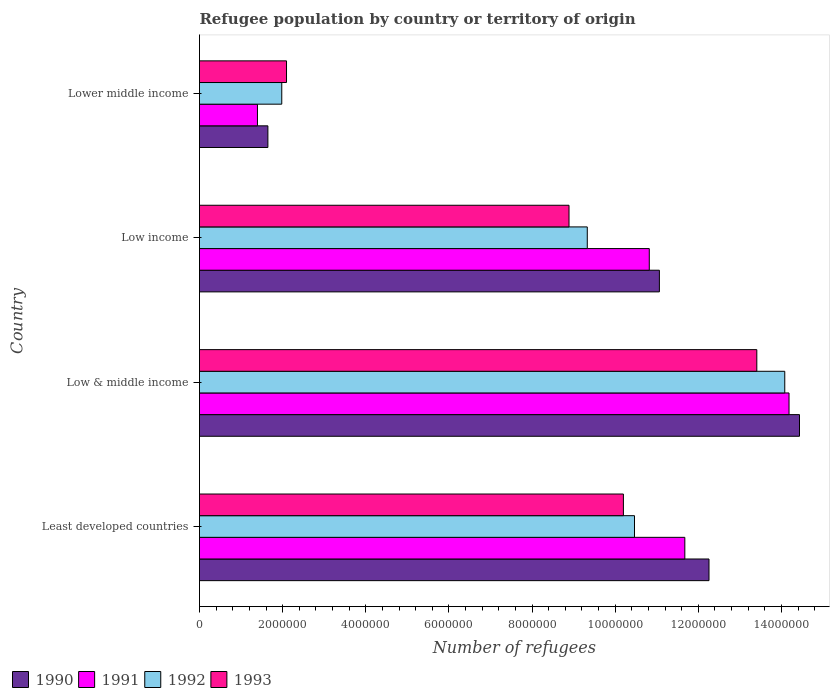How many different coloured bars are there?
Your answer should be very brief. 4. How many groups of bars are there?
Ensure brevity in your answer.  4. Are the number of bars on each tick of the Y-axis equal?
Your answer should be compact. Yes. How many bars are there on the 1st tick from the bottom?
Offer a very short reply. 4. What is the label of the 3rd group of bars from the top?
Provide a succinct answer. Low & middle income. What is the number of refugees in 1990 in Low & middle income?
Keep it short and to the point. 1.44e+07. Across all countries, what is the maximum number of refugees in 1993?
Make the answer very short. 1.34e+07. Across all countries, what is the minimum number of refugees in 1993?
Provide a short and direct response. 2.09e+06. In which country was the number of refugees in 1992 minimum?
Provide a succinct answer. Lower middle income. What is the total number of refugees in 1990 in the graph?
Make the answer very short. 3.94e+07. What is the difference between the number of refugees in 1993 in Low & middle income and that in Low income?
Give a very brief answer. 4.52e+06. What is the difference between the number of refugees in 1990 in Lower middle income and the number of refugees in 1993 in Low & middle income?
Give a very brief answer. -1.18e+07. What is the average number of refugees in 1990 per country?
Provide a short and direct response. 9.85e+06. What is the difference between the number of refugees in 1991 and number of refugees in 1992 in Low income?
Offer a terse response. 1.49e+06. In how many countries, is the number of refugees in 1991 greater than 10000000 ?
Your response must be concise. 3. What is the ratio of the number of refugees in 1992 in Least developed countries to that in Low income?
Make the answer very short. 1.12. What is the difference between the highest and the second highest number of refugees in 1993?
Make the answer very short. 3.21e+06. What is the difference between the highest and the lowest number of refugees in 1990?
Keep it short and to the point. 1.28e+07. In how many countries, is the number of refugees in 1991 greater than the average number of refugees in 1991 taken over all countries?
Keep it short and to the point. 3. Is the sum of the number of refugees in 1992 in Least developed countries and Lower middle income greater than the maximum number of refugees in 1990 across all countries?
Your response must be concise. No. How many bars are there?
Keep it short and to the point. 16. How many countries are there in the graph?
Ensure brevity in your answer.  4. What is the difference between two consecutive major ticks on the X-axis?
Offer a very short reply. 2.00e+06. Where does the legend appear in the graph?
Your answer should be compact. Bottom left. How are the legend labels stacked?
Provide a succinct answer. Horizontal. What is the title of the graph?
Offer a very short reply. Refugee population by country or territory of origin. What is the label or title of the X-axis?
Give a very brief answer. Number of refugees. What is the label or title of the Y-axis?
Offer a terse response. Country. What is the Number of refugees of 1990 in Least developed countries?
Make the answer very short. 1.23e+07. What is the Number of refugees in 1991 in Least developed countries?
Keep it short and to the point. 1.17e+07. What is the Number of refugees of 1992 in Least developed countries?
Make the answer very short. 1.05e+07. What is the Number of refugees in 1993 in Least developed countries?
Keep it short and to the point. 1.02e+07. What is the Number of refugees in 1990 in Low & middle income?
Your response must be concise. 1.44e+07. What is the Number of refugees in 1991 in Low & middle income?
Your answer should be very brief. 1.42e+07. What is the Number of refugees in 1992 in Low & middle income?
Provide a short and direct response. 1.41e+07. What is the Number of refugees of 1993 in Low & middle income?
Offer a very short reply. 1.34e+07. What is the Number of refugees in 1990 in Low income?
Your answer should be very brief. 1.11e+07. What is the Number of refugees of 1991 in Low income?
Provide a short and direct response. 1.08e+07. What is the Number of refugees in 1992 in Low income?
Offer a very short reply. 9.33e+06. What is the Number of refugees in 1993 in Low income?
Make the answer very short. 8.89e+06. What is the Number of refugees of 1990 in Lower middle income?
Offer a terse response. 1.65e+06. What is the Number of refugees in 1991 in Lower middle income?
Give a very brief answer. 1.39e+06. What is the Number of refugees of 1992 in Lower middle income?
Offer a very short reply. 1.98e+06. What is the Number of refugees in 1993 in Lower middle income?
Give a very brief answer. 2.09e+06. Across all countries, what is the maximum Number of refugees of 1990?
Keep it short and to the point. 1.44e+07. Across all countries, what is the maximum Number of refugees of 1991?
Offer a very short reply. 1.42e+07. Across all countries, what is the maximum Number of refugees of 1992?
Your answer should be compact. 1.41e+07. Across all countries, what is the maximum Number of refugees in 1993?
Keep it short and to the point. 1.34e+07. Across all countries, what is the minimum Number of refugees of 1990?
Ensure brevity in your answer.  1.65e+06. Across all countries, what is the minimum Number of refugees in 1991?
Provide a short and direct response. 1.39e+06. Across all countries, what is the minimum Number of refugees in 1992?
Ensure brevity in your answer.  1.98e+06. Across all countries, what is the minimum Number of refugees of 1993?
Your response must be concise. 2.09e+06. What is the total Number of refugees in 1990 in the graph?
Offer a terse response. 3.94e+07. What is the total Number of refugees in 1991 in the graph?
Your response must be concise. 3.81e+07. What is the total Number of refugees of 1992 in the graph?
Your answer should be very brief. 3.59e+07. What is the total Number of refugees of 1993 in the graph?
Offer a terse response. 3.46e+07. What is the difference between the Number of refugees in 1990 in Least developed countries and that in Low & middle income?
Ensure brevity in your answer.  -2.18e+06. What is the difference between the Number of refugees in 1991 in Least developed countries and that in Low & middle income?
Provide a succinct answer. -2.51e+06. What is the difference between the Number of refugees of 1992 in Least developed countries and that in Low & middle income?
Your answer should be compact. -3.62e+06. What is the difference between the Number of refugees in 1993 in Least developed countries and that in Low & middle income?
Give a very brief answer. -3.21e+06. What is the difference between the Number of refugees in 1990 in Least developed countries and that in Low income?
Provide a succinct answer. 1.19e+06. What is the difference between the Number of refugees of 1991 in Least developed countries and that in Low income?
Offer a terse response. 8.55e+05. What is the difference between the Number of refugees of 1992 in Least developed countries and that in Low income?
Offer a terse response. 1.14e+06. What is the difference between the Number of refugees in 1993 in Least developed countries and that in Low income?
Provide a short and direct response. 1.31e+06. What is the difference between the Number of refugees of 1990 in Least developed countries and that in Lower middle income?
Your answer should be very brief. 1.06e+07. What is the difference between the Number of refugees of 1991 in Least developed countries and that in Lower middle income?
Your response must be concise. 1.03e+07. What is the difference between the Number of refugees in 1992 in Least developed countries and that in Lower middle income?
Ensure brevity in your answer.  8.49e+06. What is the difference between the Number of refugees in 1993 in Least developed countries and that in Lower middle income?
Offer a very short reply. 8.11e+06. What is the difference between the Number of refugees of 1990 in Low & middle income and that in Low income?
Your answer should be compact. 3.37e+06. What is the difference between the Number of refugees of 1991 in Low & middle income and that in Low income?
Your answer should be very brief. 3.36e+06. What is the difference between the Number of refugees of 1992 in Low & middle income and that in Low income?
Your response must be concise. 4.75e+06. What is the difference between the Number of refugees in 1993 in Low & middle income and that in Low income?
Offer a terse response. 4.52e+06. What is the difference between the Number of refugees of 1990 in Low & middle income and that in Lower middle income?
Your response must be concise. 1.28e+07. What is the difference between the Number of refugees in 1991 in Low & middle income and that in Lower middle income?
Give a very brief answer. 1.28e+07. What is the difference between the Number of refugees in 1992 in Low & middle income and that in Lower middle income?
Keep it short and to the point. 1.21e+07. What is the difference between the Number of refugees of 1993 in Low & middle income and that in Lower middle income?
Offer a very short reply. 1.13e+07. What is the difference between the Number of refugees of 1990 in Low income and that in Lower middle income?
Keep it short and to the point. 9.42e+06. What is the difference between the Number of refugees in 1991 in Low income and that in Lower middle income?
Your answer should be very brief. 9.43e+06. What is the difference between the Number of refugees of 1992 in Low income and that in Lower middle income?
Offer a terse response. 7.35e+06. What is the difference between the Number of refugees in 1993 in Low income and that in Lower middle income?
Provide a short and direct response. 6.80e+06. What is the difference between the Number of refugees in 1990 in Least developed countries and the Number of refugees in 1991 in Low & middle income?
Provide a short and direct response. -1.93e+06. What is the difference between the Number of refugees of 1990 in Least developed countries and the Number of refugees of 1992 in Low & middle income?
Give a very brief answer. -1.82e+06. What is the difference between the Number of refugees of 1990 in Least developed countries and the Number of refugees of 1993 in Low & middle income?
Provide a succinct answer. -1.15e+06. What is the difference between the Number of refugees in 1991 in Least developed countries and the Number of refugees in 1992 in Low & middle income?
Provide a succinct answer. -2.40e+06. What is the difference between the Number of refugees in 1991 in Least developed countries and the Number of refugees in 1993 in Low & middle income?
Offer a terse response. -1.73e+06. What is the difference between the Number of refugees in 1992 in Least developed countries and the Number of refugees in 1993 in Low & middle income?
Offer a very short reply. -2.94e+06. What is the difference between the Number of refugees of 1990 in Least developed countries and the Number of refugees of 1991 in Low income?
Provide a short and direct response. 1.44e+06. What is the difference between the Number of refugees in 1990 in Least developed countries and the Number of refugees in 1992 in Low income?
Provide a succinct answer. 2.93e+06. What is the difference between the Number of refugees of 1990 in Least developed countries and the Number of refugees of 1993 in Low income?
Your answer should be very brief. 3.37e+06. What is the difference between the Number of refugees of 1991 in Least developed countries and the Number of refugees of 1992 in Low income?
Offer a terse response. 2.35e+06. What is the difference between the Number of refugees in 1991 in Least developed countries and the Number of refugees in 1993 in Low income?
Make the answer very short. 2.79e+06. What is the difference between the Number of refugees in 1992 in Least developed countries and the Number of refugees in 1993 in Low income?
Offer a very short reply. 1.58e+06. What is the difference between the Number of refugees in 1990 in Least developed countries and the Number of refugees in 1991 in Lower middle income?
Provide a short and direct response. 1.09e+07. What is the difference between the Number of refugees in 1990 in Least developed countries and the Number of refugees in 1992 in Lower middle income?
Offer a very short reply. 1.03e+07. What is the difference between the Number of refugees in 1990 in Least developed countries and the Number of refugees in 1993 in Lower middle income?
Make the answer very short. 1.02e+07. What is the difference between the Number of refugees in 1991 in Least developed countries and the Number of refugees in 1992 in Lower middle income?
Provide a succinct answer. 9.70e+06. What is the difference between the Number of refugees in 1991 in Least developed countries and the Number of refugees in 1993 in Lower middle income?
Your response must be concise. 9.58e+06. What is the difference between the Number of refugees of 1992 in Least developed countries and the Number of refugees of 1993 in Lower middle income?
Make the answer very short. 8.37e+06. What is the difference between the Number of refugees of 1990 in Low & middle income and the Number of refugees of 1991 in Low income?
Your response must be concise. 3.61e+06. What is the difference between the Number of refugees of 1990 in Low & middle income and the Number of refugees of 1992 in Low income?
Provide a succinct answer. 5.11e+06. What is the difference between the Number of refugees of 1990 in Low & middle income and the Number of refugees of 1993 in Low income?
Offer a terse response. 5.55e+06. What is the difference between the Number of refugees in 1991 in Low & middle income and the Number of refugees in 1992 in Low income?
Keep it short and to the point. 4.85e+06. What is the difference between the Number of refugees in 1991 in Low & middle income and the Number of refugees in 1993 in Low income?
Offer a very short reply. 5.29e+06. What is the difference between the Number of refugees in 1992 in Low & middle income and the Number of refugees in 1993 in Low income?
Keep it short and to the point. 5.19e+06. What is the difference between the Number of refugees of 1990 in Low & middle income and the Number of refugees of 1991 in Lower middle income?
Keep it short and to the point. 1.30e+07. What is the difference between the Number of refugees in 1990 in Low & middle income and the Number of refugees in 1992 in Lower middle income?
Your answer should be very brief. 1.25e+07. What is the difference between the Number of refugees of 1990 in Low & middle income and the Number of refugees of 1993 in Lower middle income?
Make the answer very short. 1.23e+07. What is the difference between the Number of refugees in 1991 in Low & middle income and the Number of refugees in 1992 in Lower middle income?
Keep it short and to the point. 1.22e+07. What is the difference between the Number of refugees in 1991 in Low & middle income and the Number of refugees in 1993 in Lower middle income?
Make the answer very short. 1.21e+07. What is the difference between the Number of refugees of 1992 in Low & middle income and the Number of refugees of 1993 in Lower middle income?
Offer a terse response. 1.20e+07. What is the difference between the Number of refugees of 1990 in Low income and the Number of refugees of 1991 in Lower middle income?
Give a very brief answer. 9.67e+06. What is the difference between the Number of refugees of 1990 in Low income and the Number of refugees of 1992 in Lower middle income?
Keep it short and to the point. 9.09e+06. What is the difference between the Number of refugees in 1990 in Low income and the Number of refugees in 1993 in Lower middle income?
Make the answer very short. 8.97e+06. What is the difference between the Number of refugees in 1991 in Low income and the Number of refugees in 1992 in Lower middle income?
Provide a short and direct response. 8.84e+06. What is the difference between the Number of refugees of 1991 in Low income and the Number of refugees of 1993 in Lower middle income?
Give a very brief answer. 8.73e+06. What is the difference between the Number of refugees of 1992 in Low income and the Number of refugees of 1993 in Lower middle income?
Your answer should be very brief. 7.24e+06. What is the average Number of refugees in 1990 per country?
Your answer should be very brief. 9.85e+06. What is the average Number of refugees of 1991 per country?
Your response must be concise. 9.52e+06. What is the average Number of refugees in 1992 per country?
Offer a very short reply. 8.96e+06. What is the average Number of refugees of 1993 per country?
Your response must be concise. 8.65e+06. What is the difference between the Number of refugees in 1990 and Number of refugees in 1991 in Least developed countries?
Give a very brief answer. 5.82e+05. What is the difference between the Number of refugees in 1990 and Number of refugees in 1992 in Least developed countries?
Give a very brief answer. 1.79e+06. What is the difference between the Number of refugees in 1990 and Number of refugees in 1993 in Least developed countries?
Offer a very short reply. 2.06e+06. What is the difference between the Number of refugees of 1991 and Number of refugees of 1992 in Least developed countries?
Give a very brief answer. 1.21e+06. What is the difference between the Number of refugees in 1991 and Number of refugees in 1993 in Least developed countries?
Your answer should be very brief. 1.48e+06. What is the difference between the Number of refugees of 1992 and Number of refugees of 1993 in Least developed countries?
Make the answer very short. 2.67e+05. What is the difference between the Number of refugees in 1990 and Number of refugees in 1991 in Low & middle income?
Your answer should be very brief. 2.52e+05. What is the difference between the Number of refugees of 1990 and Number of refugees of 1992 in Low & middle income?
Keep it short and to the point. 3.54e+05. What is the difference between the Number of refugees in 1990 and Number of refugees in 1993 in Low & middle income?
Offer a very short reply. 1.03e+06. What is the difference between the Number of refugees in 1991 and Number of refugees in 1992 in Low & middle income?
Your answer should be compact. 1.02e+05. What is the difference between the Number of refugees in 1991 and Number of refugees in 1993 in Low & middle income?
Offer a terse response. 7.75e+05. What is the difference between the Number of refugees of 1992 and Number of refugees of 1993 in Low & middle income?
Your response must be concise. 6.73e+05. What is the difference between the Number of refugees in 1990 and Number of refugees in 1991 in Low income?
Make the answer very short. 2.43e+05. What is the difference between the Number of refugees of 1990 and Number of refugees of 1992 in Low income?
Offer a terse response. 1.73e+06. What is the difference between the Number of refugees in 1990 and Number of refugees in 1993 in Low income?
Keep it short and to the point. 2.17e+06. What is the difference between the Number of refugees of 1991 and Number of refugees of 1992 in Low income?
Provide a succinct answer. 1.49e+06. What is the difference between the Number of refugees in 1991 and Number of refugees in 1993 in Low income?
Keep it short and to the point. 1.93e+06. What is the difference between the Number of refugees in 1992 and Number of refugees in 1993 in Low income?
Your answer should be very brief. 4.40e+05. What is the difference between the Number of refugees in 1990 and Number of refugees in 1991 in Lower middle income?
Give a very brief answer. 2.51e+05. What is the difference between the Number of refugees in 1990 and Number of refugees in 1992 in Lower middle income?
Give a very brief answer. -3.34e+05. What is the difference between the Number of refugees in 1990 and Number of refugees in 1993 in Lower middle income?
Provide a succinct answer. -4.48e+05. What is the difference between the Number of refugees in 1991 and Number of refugees in 1992 in Lower middle income?
Your answer should be very brief. -5.85e+05. What is the difference between the Number of refugees of 1991 and Number of refugees of 1993 in Lower middle income?
Give a very brief answer. -6.99e+05. What is the difference between the Number of refugees of 1992 and Number of refugees of 1993 in Lower middle income?
Keep it short and to the point. -1.15e+05. What is the ratio of the Number of refugees in 1990 in Least developed countries to that in Low & middle income?
Your response must be concise. 0.85. What is the ratio of the Number of refugees of 1991 in Least developed countries to that in Low & middle income?
Give a very brief answer. 0.82. What is the ratio of the Number of refugees of 1992 in Least developed countries to that in Low & middle income?
Give a very brief answer. 0.74. What is the ratio of the Number of refugees in 1993 in Least developed countries to that in Low & middle income?
Give a very brief answer. 0.76. What is the ratio of the Number of refugees in 1990 in Least developed countries to that in Low income?
Your answer should be compact. 1.11. What is the ratio of the Number of refugees of 1991 in Least developed countries to that in Low income?
Offer a very short reply. 1.08. What is the ratio of the Number of refugees of 1992 in Least developed countries to that in Low income?
Your answer should be compact. 1.12. What is the ratio of the Number of refugees in 1993 in Least developed countries to that in Low income?
Ensure brevity in your answer.  1.15. What is the ratio of the Number of refugees in 1990 in Least developed countries to that in Lower middle income?
Offer a terse response. 7.45. What is the ratio of the Number of refugees of 1991 in Least developed countries to that in Lower middle income?
Provide a short and direct response. 8.37. What is the ratio of the Number of refugees of 1992 in Least developed countries to that in Lower middle income?
Offer a very short reply. 5.29. What is the ratio of the Number of refugees of 1993 in Least developed countries to that in Lower middle income?
Keep it short and to the point. 4.87. What is the ratio of the Number of refugees of 1990 in Low & middle income to that in Low income?
Your answer should be very brief. 1.3. What is the ratio of the Number of refugees of 1991 in Low & middle income to that in Low income?
Your response must be concise. 1.31. What is the ratio of the Number of refugees of 1992 in Low & middle income to that in Low income?
Make the answer very short. 1.51. What is the ratio of the Number of refugees of 1993 in Low & middle income to that in Low income?
Offer a very short reply. 1.51. What is the ratio of the Number of refugees of 1990 in Low & middle income to that in Lower middle income?
Give a very brief answer. 8.77. What is the ratio of the Number of refugees of 1991 in Low & middle income to that in Lower middle income?
Give a very brief answer. 10.17. What is the ratio of the Number of refugees of 1992 in Low & middle income to that in Lower middle income?
Your answer should be compact. 7.12. What is the ratio of the Number of refugees in 1993 in Low & middle income to that in Lower middle income?
Your answer should be compact. 6.4. What is the ratio of the Number of refugees in 1990 in Low income to that in Lower middle income?
Give a very brief answer. 6.73. What is the ratio of the Number of refugees of 1991 in Low income to that in Lower middle income?
Offer a terse response. 7.76. What is the ratio of the Number of refugees in 1992 in Low income to that in Lower middle income?
Your answer should be compact. 4.71. What is the ratio of the Number of refugees of 1993 in Low income to that in Lower middle income?
Keep it short and to the point. 4.25. What is the difference between the highest and the second highest Number of refugees in 1990?
Keep it short and to the point. 2.18e+06. What is the difference between the highest and the second highest Number of refugees in 1991?
Your answer should be compact. 2.51e+06. What is the difference between the highest and the second highest Number of refugees in 1992?
Offer a terse response. 3.62e+06. What is the difference between the highest and the second highest Number of refugees in 1993?
Your response must be concise. 3.21e+06. What is the difference between the highest and the lowest Number of refugees of 1990?
Ensure brevity in your answer.  1.28e+07. What is the difference between the highest and the lowest Number of refugees in 1991?
Ensure brevity in your answer.  1.28e+07. What is the difference between the highest and the lowest Number of refugees of 1992?
Provide a short and direct response. 1.21e+07. What is the difference between the highest and the lowest Number of refugees of 1993?
Keep it short and to the point. 1.13e+07. 